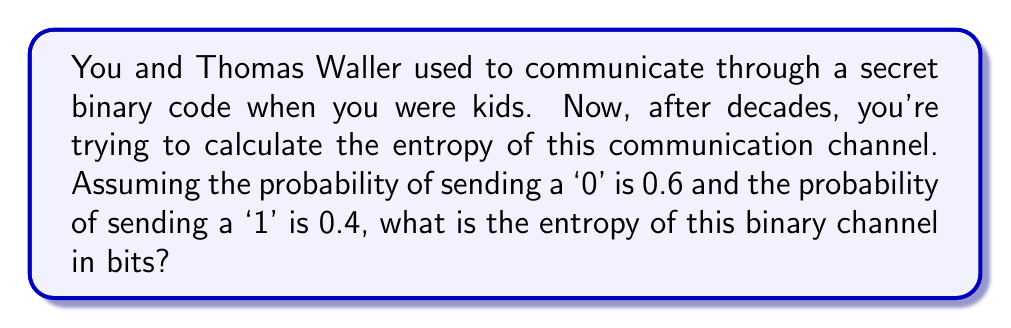Can you answer this question? To calculate the entropy of a binary communication channel, we use Shannon's entropy formula:

$$H = -\sum_{i=1}^n p_i \log_2(p_i)$$

Where:
- $H$ is the entropy in bits
- $p_i$ is the probability of each possible outcome
- $n$ is the number of possible outcomes (in this case, 2 for a binary channel)

Given:
- Probability of sending '0': $p_0 = 0.6$
- Probability of sending '1': $p_1 = 0.4$

Step 1: Apply the entropy formula
$$H = -[p_0 \log_2(p_0) + p_1 \log_2(p_1)]$$

Step 2: Substitute the values
$$H = -[0.6 \log_2(0.6) + 0.4 \log_2(0.4)]$$

Step 3: Calculate the logarithms
$\log_2(0.6) \approx -0.7370$
$\log_2(0.4) \approx -1.3219$

Step 4: Multiply each probability by its logarithm
$0.6 \times (-0.7370) \approx -0.4422$
$0.4 \times (-1.3219) \approx -0.5288$

Step 5: Sum the results and take the negative
$$H = -[(-0.4422) + (-0.5288)] \approx 0.9710$$

Therefore, the entropy of the binary channel is approximately 0.9710 bits.
Answer: 0.9710 bits 